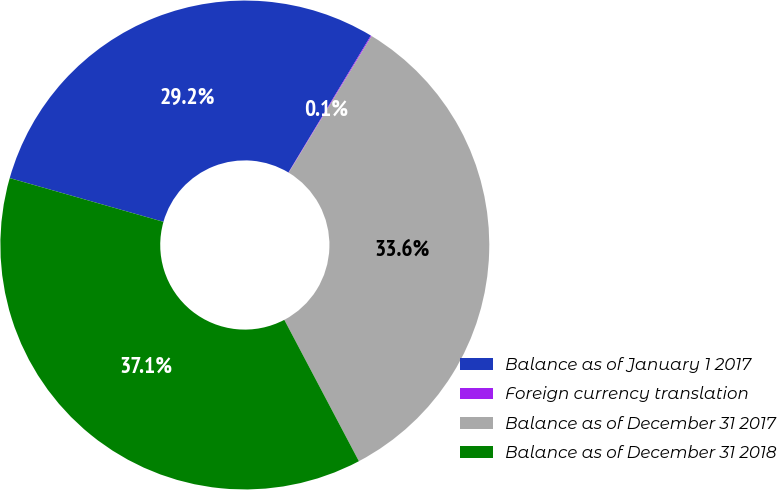Convert chart to OTSL. <chart><loc_0><loc_0><loc_500><loc_500><pie_chart><fcel>Balance as of January 1 2017<fcel>Foreign currency translation<fcel>Balance as of December 31 2017<fcel>Balance as of December 31 2018<nl><fcel>29.21%<fcel>0.06%<fcel>33.59%<fcel>37.14%<nl></chart> 